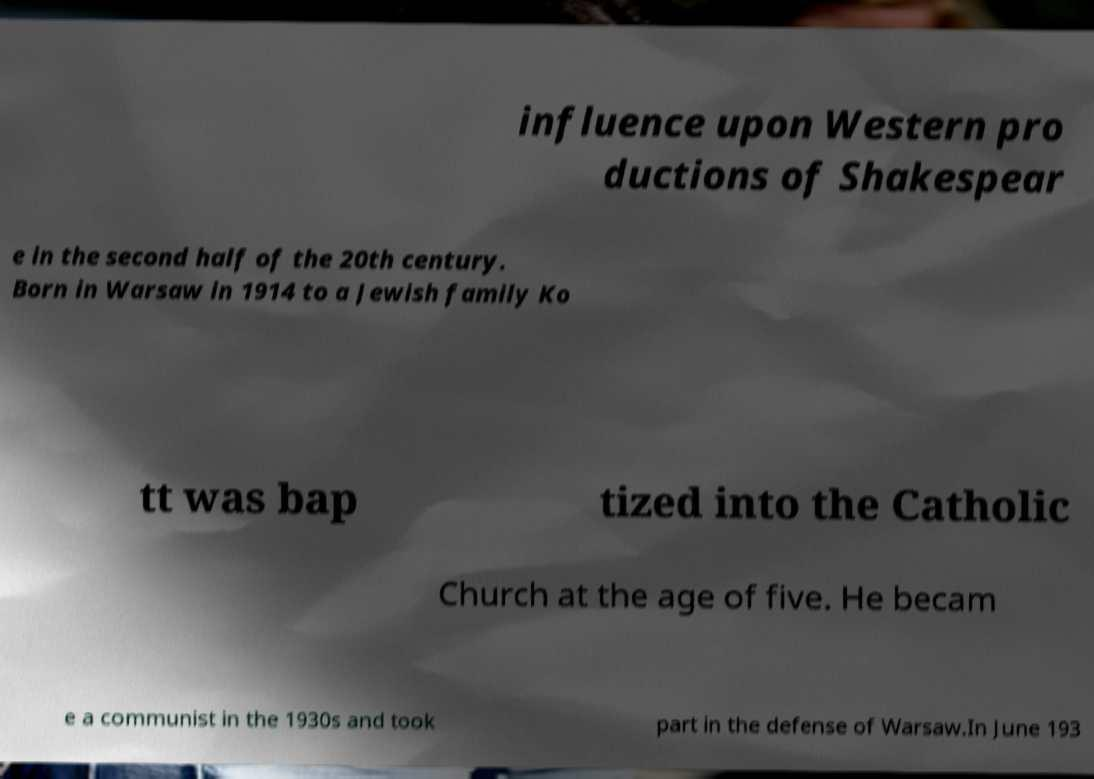For documentation purposes, I need the text within this image transcribed. Could you provide that? influence upon Western pro ductions of Shakespear e in the second half of the 20th century. Born in Warsaw in 1914 to a Jewish family Ko tt was bap tized into the Catholic Church at the age of five. He becam e a communist in the 1930s and took part in the defense of Warsaw.In June 193 